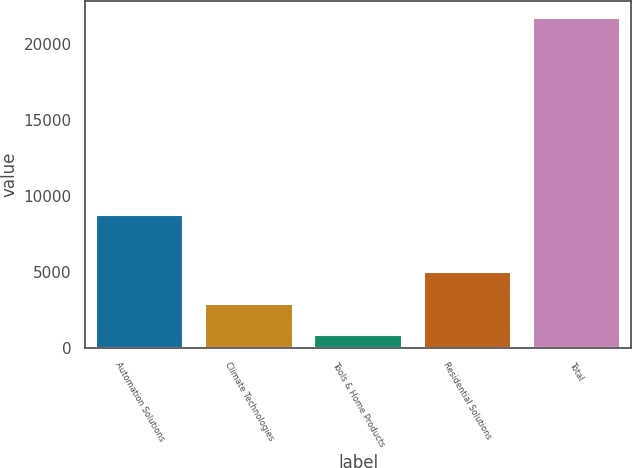Convert chart. <chart><loc_0><loc_0><loc_500><loc_500><bar_chart><fcel>Automation Solutions<fcel>Climate Technologies<fcel>Tools & Home Products<fcel>Residential Solutions<fcel>Total<nl><fcel>8759<fcel>2901.3<fcel>809<fcel>4993.6<fcel>21732<nl></chart> 